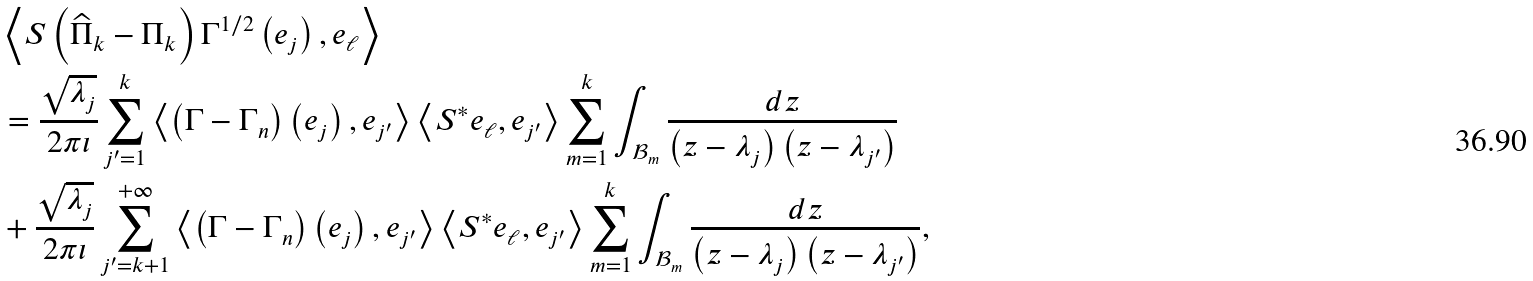<formula> <loc_0><loc_0><loc_500><loc_500>& \left \langle S \left ( \widehat { \Pi } _ { k } - \Pi _ { k } \right ) \Gamma ^ { 1 / 2 } \left ( e _ { j } \right ) , e _ { \ell } \right \rangle \\ & = \frac { \sqrt { \lambda _ { j } } } { 2 \pi \iota } \sum _ { j ^ { \prime } = 1 } ^ { k } \left \langle \left ( \Gamma - \Gamma _ { n } \right ) \left ( e _ { j } \right ) , e _ { j ^ { \prime } } \right \rangle \left \langle S ^ { \ast } e _ { \ell } , e _ { j ^ { \prime } } \right \rangle \sum _ { m = 1 } ^ { k } \int _ { \mathcal { B } _ { m } } \frac { d z } { \left ( z - \lambda _ { j } \right ) \left ( z - \lambda _ { j ^ { \prime } } \right ) } \\ & + \frac { \sqrt { \lambda _ { j } } } { 2 \pi \iota } \sum _ { j ^ { \prime } = k + 1 } ^ { + \infty } \left \langle \left ( \Gamma - \Gamma _ { n } \right ) \left ( e _ { j } \right ) , e _ { j ^ { \prime } } \right \rangle \left \langle S ^ { \ast } e _ { \ell } , e _ { j ^ { \prime } } \right \rangle \sum _ { m = 1 } ^ { k } \int _ { \mathcal { B } _ { m } } \frac { d z } { \left ( z - \lambda _ { j } \right ) \left ( z - \lambda _ { j ^ { \prime } } \right ) } ,</formula> 